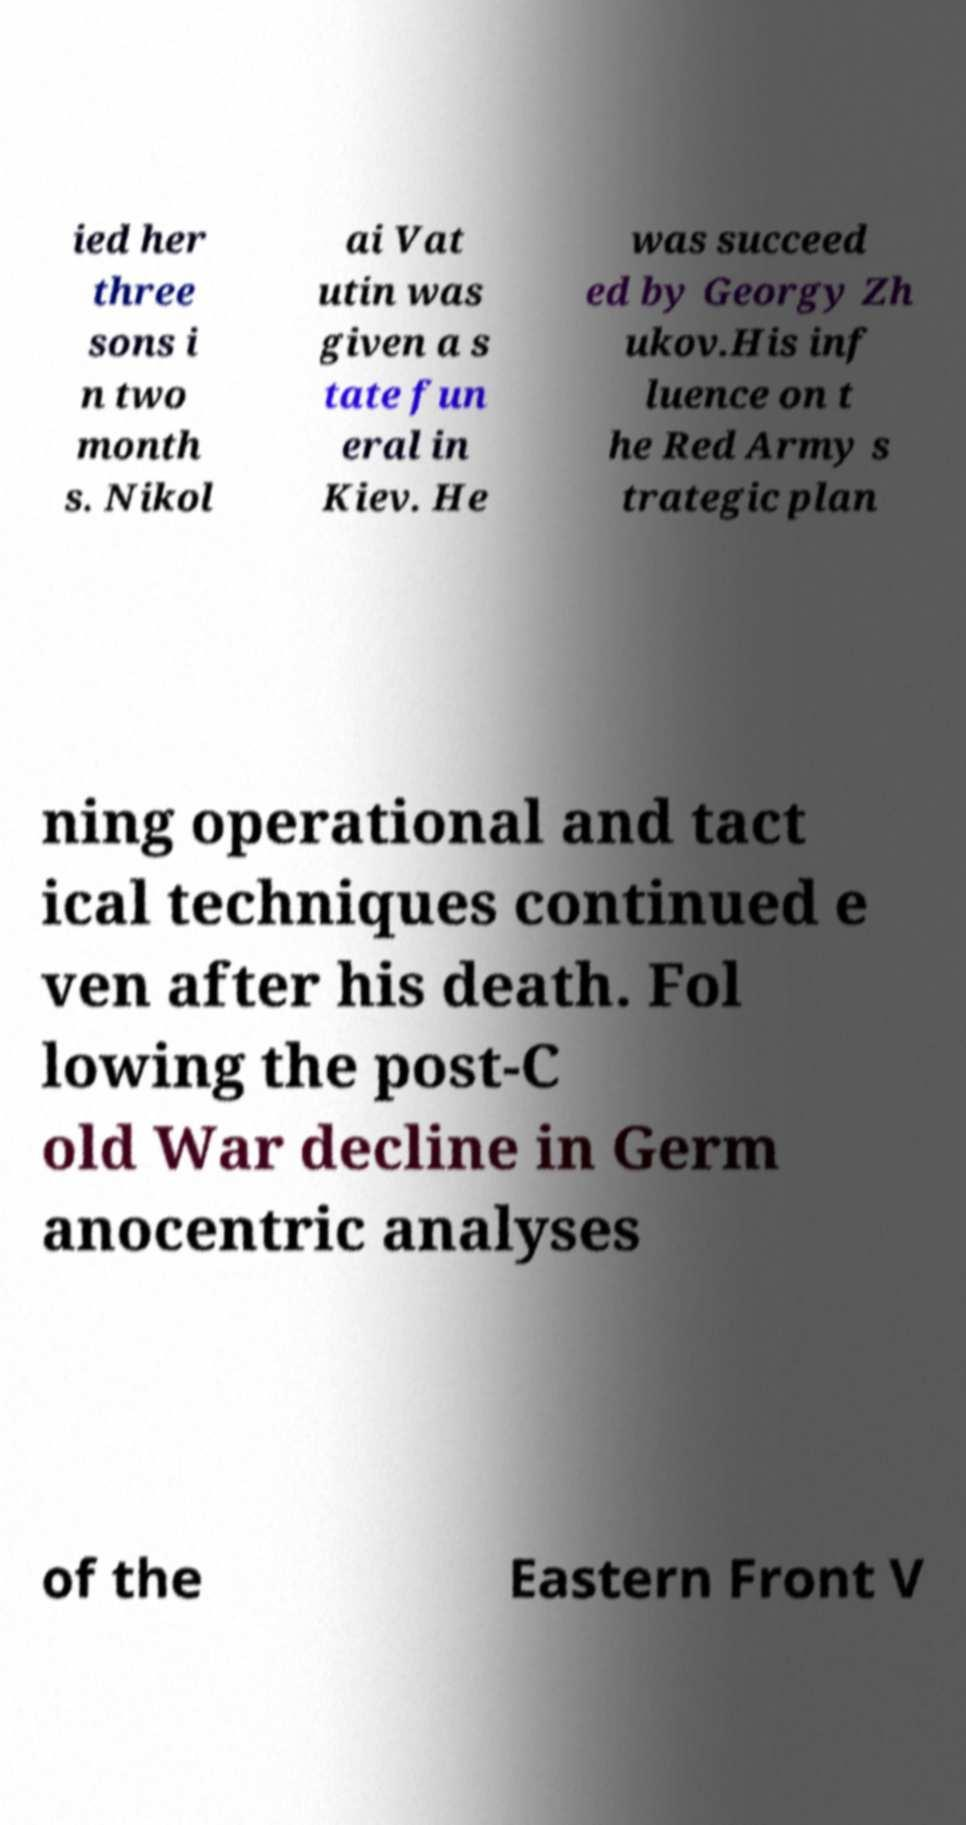Could you extract and type out the text from this image? ied her three sons i n two month s. Nikol ai Vat utin was given a s tate fun eral in Kiev. He was succeed ed by Georgy Zh ukov.His inf luence on t he Red Army s trategic plan ning operational and tact ical techniques continued e ven after his death. Fol lowing the post-C old War decline in Germ anocentric analyses of the Eastern Front V 